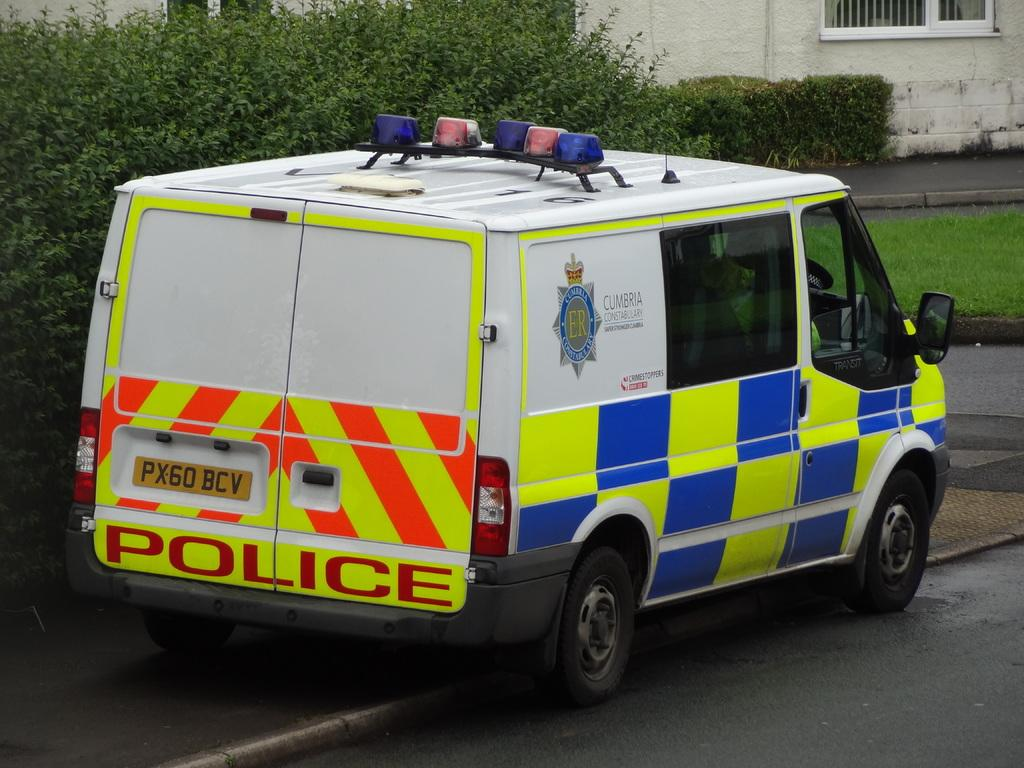<image>
Provide a brief description of the given image. A police van is illegally parked across a path. 